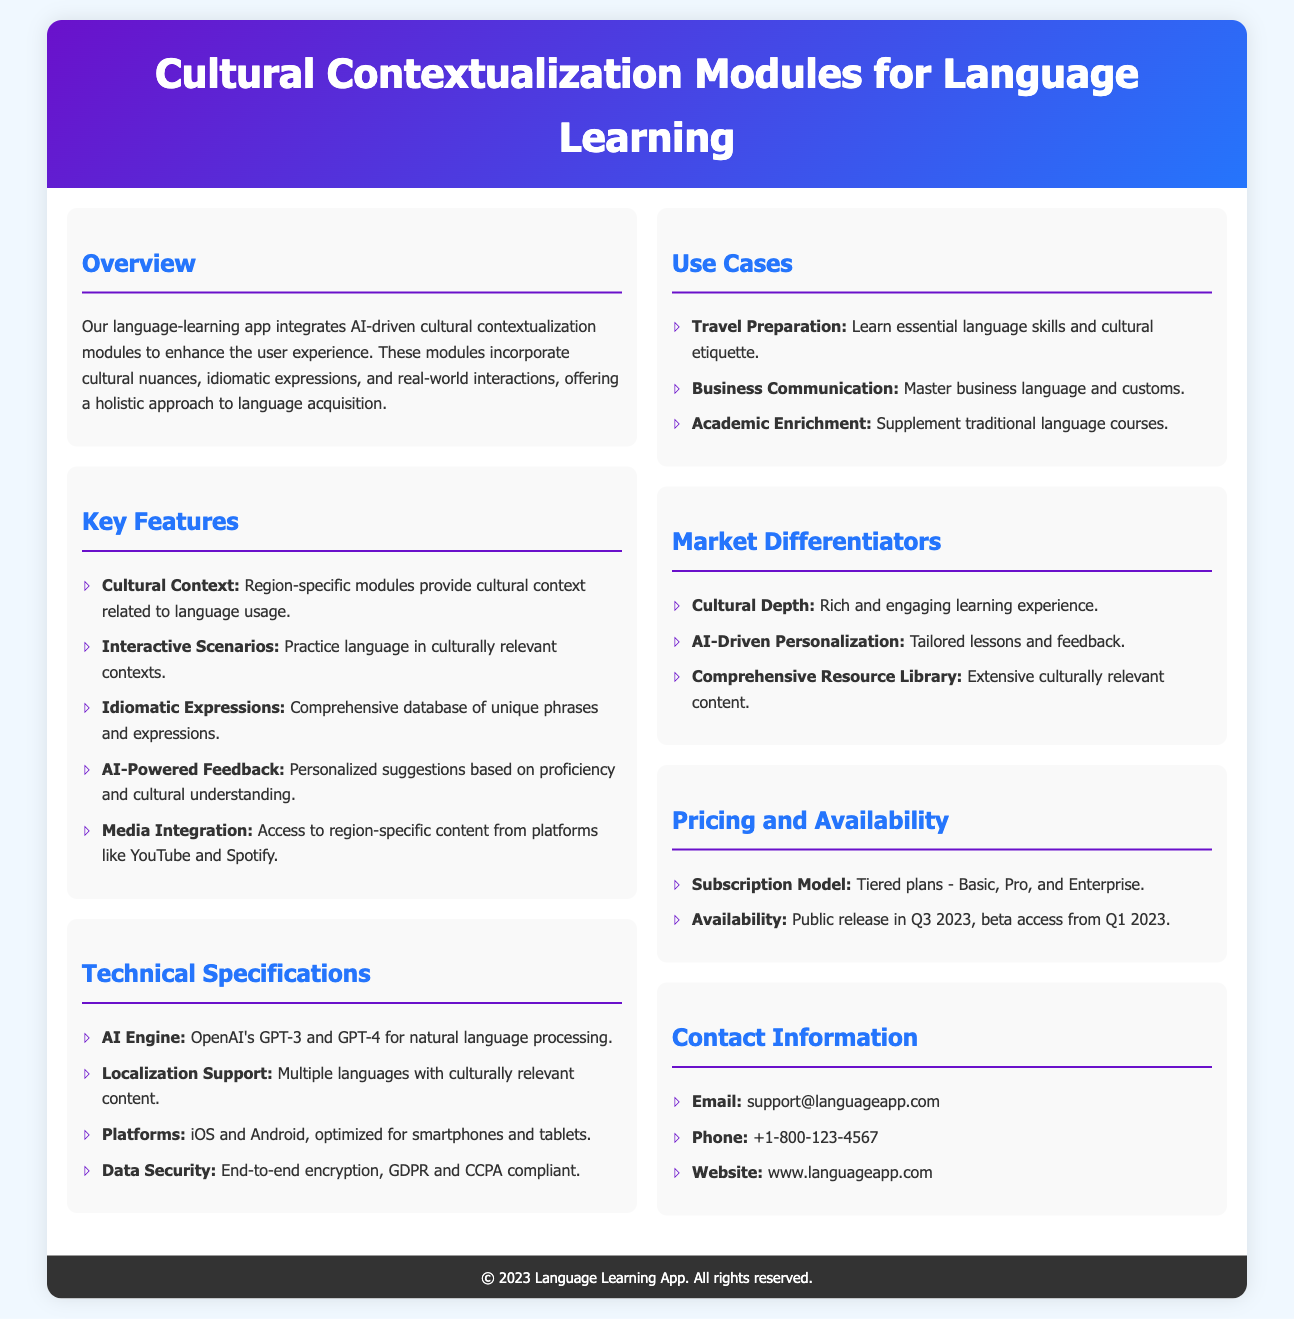What is the main purpose of the cultural contextualization modules? The document states that the modules enhance the user experience by incorporating cultural nuances, idiomatic expressions, and real-world interactions; thus, the main purpose is to offer a holistic approach to language acquisition.
Answer: enhance user experience Which AI engine is used in the app? The technical specifications section lists OpenAI's GPT-3 and GPT-4 as the AI engines used for natural language processing.
Answer: OpenAI's GPT-3 and GPT-4 What types of scenarios can users practice language in? The key features section describes that users can practice in "culturally relevant contexts".
Answer: culturally relevant contexts When is the public release scheduled? In the pricing and availability section, the document specifies that the public release is in Q3 2023.
Answer: Q3 2023 What are the subscription tiers available? The pricing and availability section mentions three tiers available for subscription plans: Basic, Pro, and Enterprise.
Answer: Basic, Pro, and Enterprise What type of learning experience is emphasized in the market differentiators? The market differentiators section highlights a "rich and engaging learning experience" as a key focus.
Answer: rich and engaging learning experience How many use cases are listed in the document? The use cases section enumerates three specific use cases for the app, thus there are three listed.
Answer: three What is provided to users based on their proficiency? The key features section includes “personalized suggestions” based on users' proficiency and cultural understanding.
Answer: personalized suggestions 